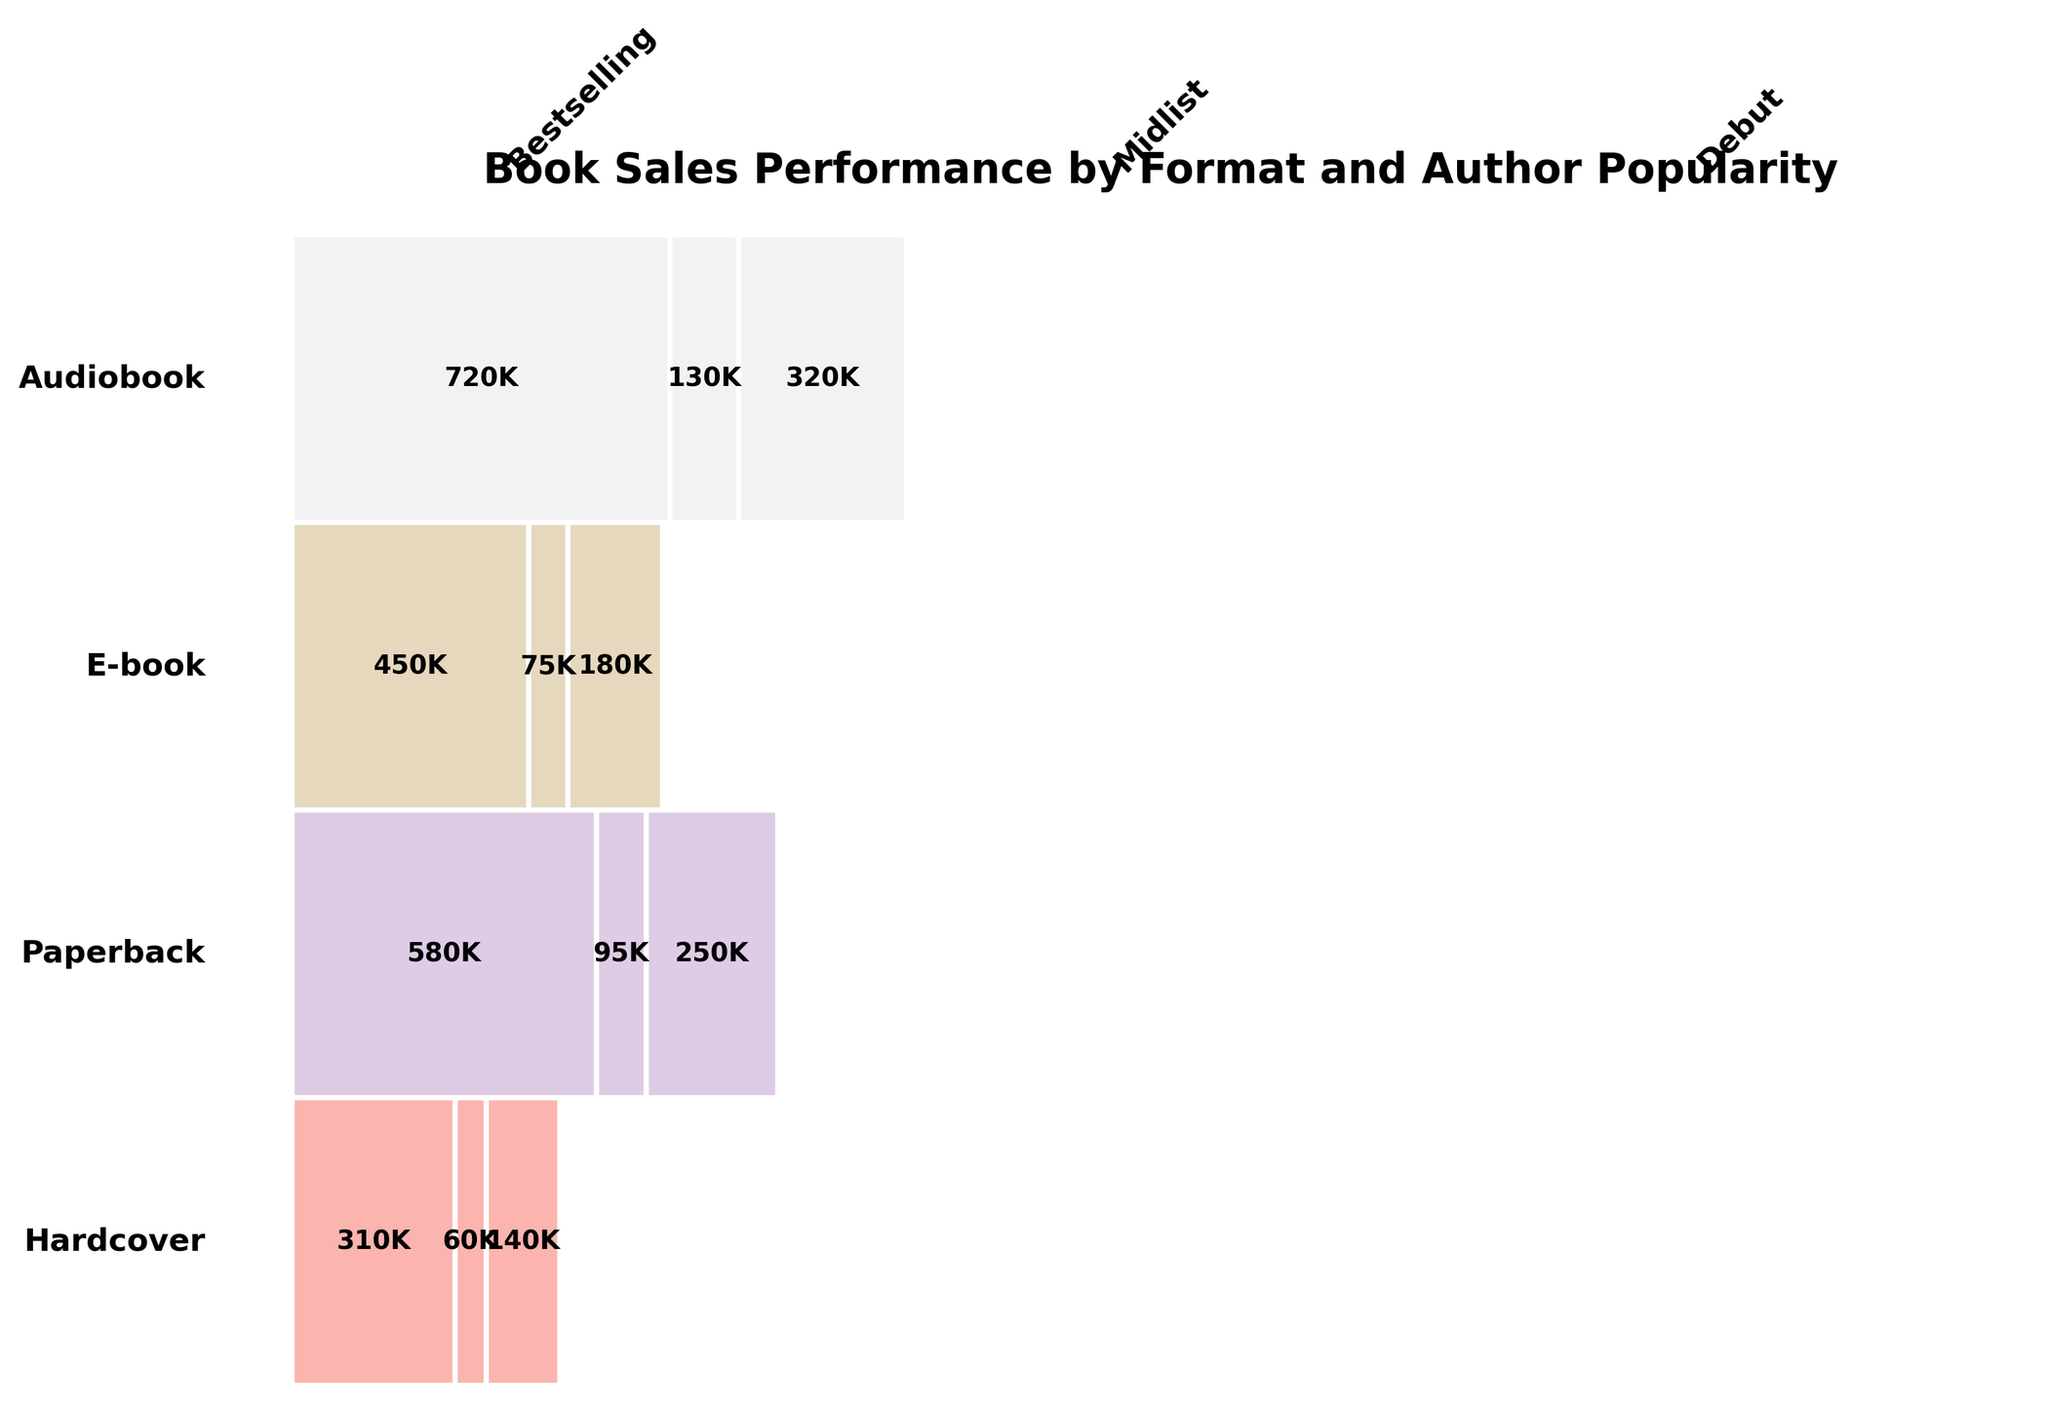What's the title of the plot? The title of the plot is prominently displayed at the top of the figure. It is styled in bold to catch the viewer's attention.
Answer: Book Sales Performance by Format and Author Popularity Which format has the highest sales for Bestselling authors? To find the highest sales for Bestselling authors, look at the Bestselling category for each format and identify the largest figure.
Answer: Paperback What is the total number of sales for Midlist authors across all formats? Add the sales numbers for Midlist authors across Hardcover, Paperback, E-book, and Audiobook formats: 180K + 320K + 250K + 140K. The sum of these values will provide the answer.
Answer: 890K How does the sales performance of E-books for Debut authors compare to that of Audiobooks for Bestselling authors? Compare the sales numbers given for E-books in the Debut category and Audiobooks in the Bestselling category: 95K for E-books (Debut) against 310K for Audiobooks (Bestselling).
Answer: Audiobooks (Bestselling) have higher sales What is the proportion of Midlist author sales to total sales in the Hardcover format? Sum all sales in the Hardcover format and then calculate the proportion of Midlist author sales: Midlist (180K) / (Bestselling + Midlist + Debut) = 180K / (450K + 180K + 75K).
Answer: 180/705 Between Paperback and E-book formats, which one shows a higher sales figure for Debut authors? Compare the sales numbers for Debut authors in Paperback and E-book formats: 130K for Paperback vs. 95K for E-books.
Answer: Paperback What's the cumulative sales figure for Bestselling authors across all formats? Add the sales numbers for Bestselling authors across Hardcover, Paperback, E-book, and Audiobook formats: 450K + 720K + 580K + 310K. The sum of these values will provide the answer.
Answer: 2060K In which format do Debut authors perform the best in terms of sales? Identify the highest sales figure for Debut authors across all formats: Hardcover (75K), Paperback (130K), E-book (95K), Audiobook (60K).
Answer: Paperback Which format has the lowest overall sales across all author popularity categories? Sum the sales for each format across all categories and identify which one is the lowest: Hardcover (705K), Paperback (1170K), E-book (925K), Audiobook (510K).
Answer: Audiobook What is the relative proportion of Bestselling authors' sales in E-books compared to their sales in Hardcover? Normalize sales by calculating the fraction of Bestselling authors' sales in E-books and Hardcover: E-book (580K) / Hardcover (450K).
Answer: 580/450 